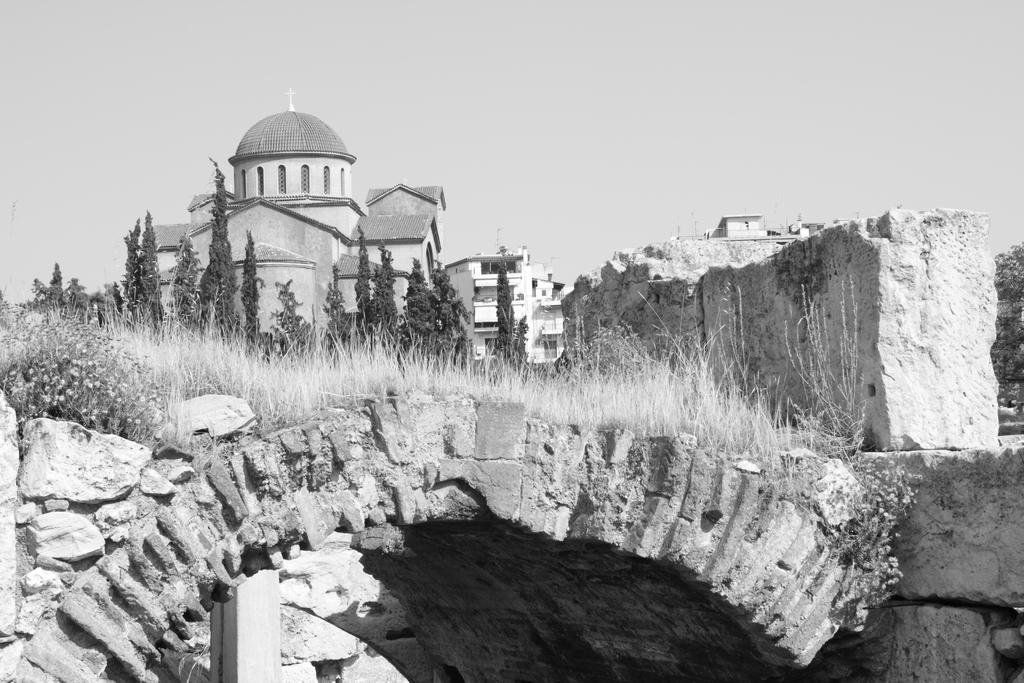What type of vegetation is on the roof in the image? There is grass on the roof in the image. What material is the roof made of? The roof is made of rocks. What can be seen in the background of the image? Trees and buildings are present in the background of the image. What type of lettuce is growing on the roof in the image? There is no lettuce present on the roof in the image; it is grass. What is the reaction of the buildings to the presence of the grass on the roof? The image does not show any reaction from the buildings, as it is a still image. 